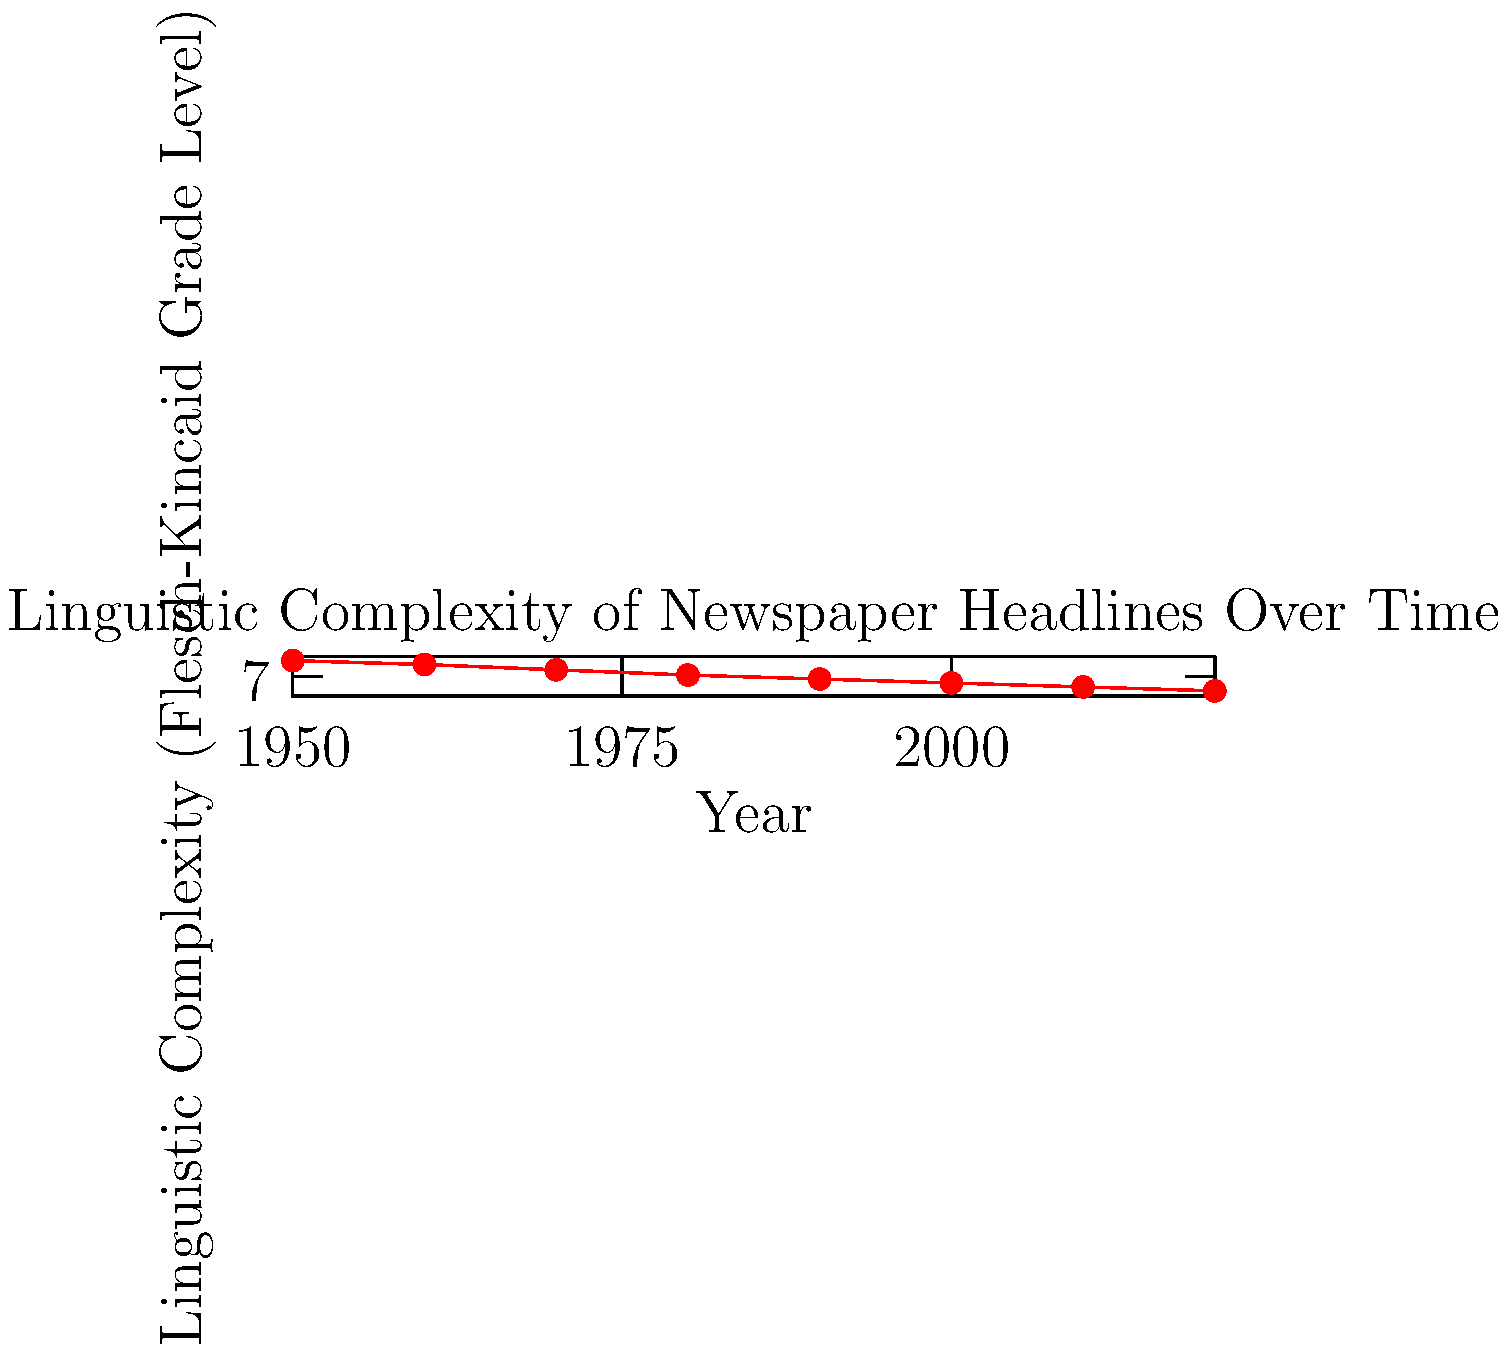Analyzing the graph, which decade saw the steepest decline in the linguistic complexity of newspaper headlines, and what linguistic phenomenon might explain this trend? To answer this question, we need to follow these steps:

1. Examine the graph to identify the steepest decline in linguistic complexity.
2. Calculate the rate of change for each decade.
3. Determine which decade had the highest rate of change.
4. Consider linguistic phenomena that could explain this trend.

Step 1: Visual inspection suggests the steepest decline occurred between 1950 and 1970.

Step 2: Calculate the rate of change for each decade:
1950-1960: $(7.9 - 8.2) / 10 = -0.03$ per year
1960-1970: $(7.5 - 7.9) / 10 = -0.04$ per year
1970-1980: $(7.1 - 7.5) / 10 = -0.04$ per year
1980-1990: $(6.8 - 7.1) / 10 = -0.03$ per year
1990-2000: $(6.5 - 6.8) / 10 = -0.03$ per year
2000-2010: $(6.2 - 6.5) / 10 = -0.03$ per year
2010-2020: $(5.9 - 6.2) / 10 = -0.03$ per year

Step 3: The steepest decline occurred in the 1960s and 1970s, with a rate of -0.04 per year.

Step 4: This trend could be explained by the rise of telegraphic style in journalism, which emphasizes brevity and conciseness. This style became more prevalent in the 1960s and 1970s due to:

a) Increased competition for readers' attention
b) Influence of television news, which used shorter soundbites
c) Space constraints in print media
d) Changing reader preferences for more digestible information

The trend towards simpler language in headlines continued in subsequent decades, albeit at a slower rate, reflecting a broader shift in journalistic style and public discourse.
Answer: 1960s-1970s; rise of telegraphic style in journalism 